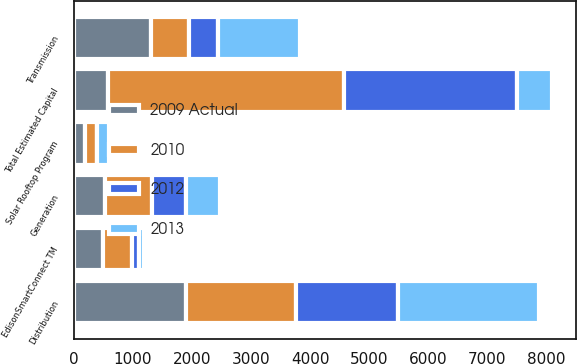Convert chart to OTSL. <chart><loc_0><loc_0><loc_500><loc_500><stacked_bar_chart><ecel><fcel>Distribution<fcel>Transmission<fcel>Generation<fcel>EdisonSmartConnect TM<fcel>Solar Rooftop Program<fcel>Total Estimated Capital<nl><fcel>2012<fcel>1732<fcel>490<fcel>585<fcel>123<fcel>8<fcel>2938<nl><fcel>2010<fcel>1855<fcel>652<fcel>789<fcel>496<fcel>191<fcel>3983<nl><fcel>2009 Actual<fcel>1906<fcel>1300<fcel>528<fcel>491<fcel>197<fcel>582.5<nl><fcel>2013<fcel>2387<fcel>1391<fcel>580<fcel>74<fcel>203<fcel>582.5<nl></chart> 